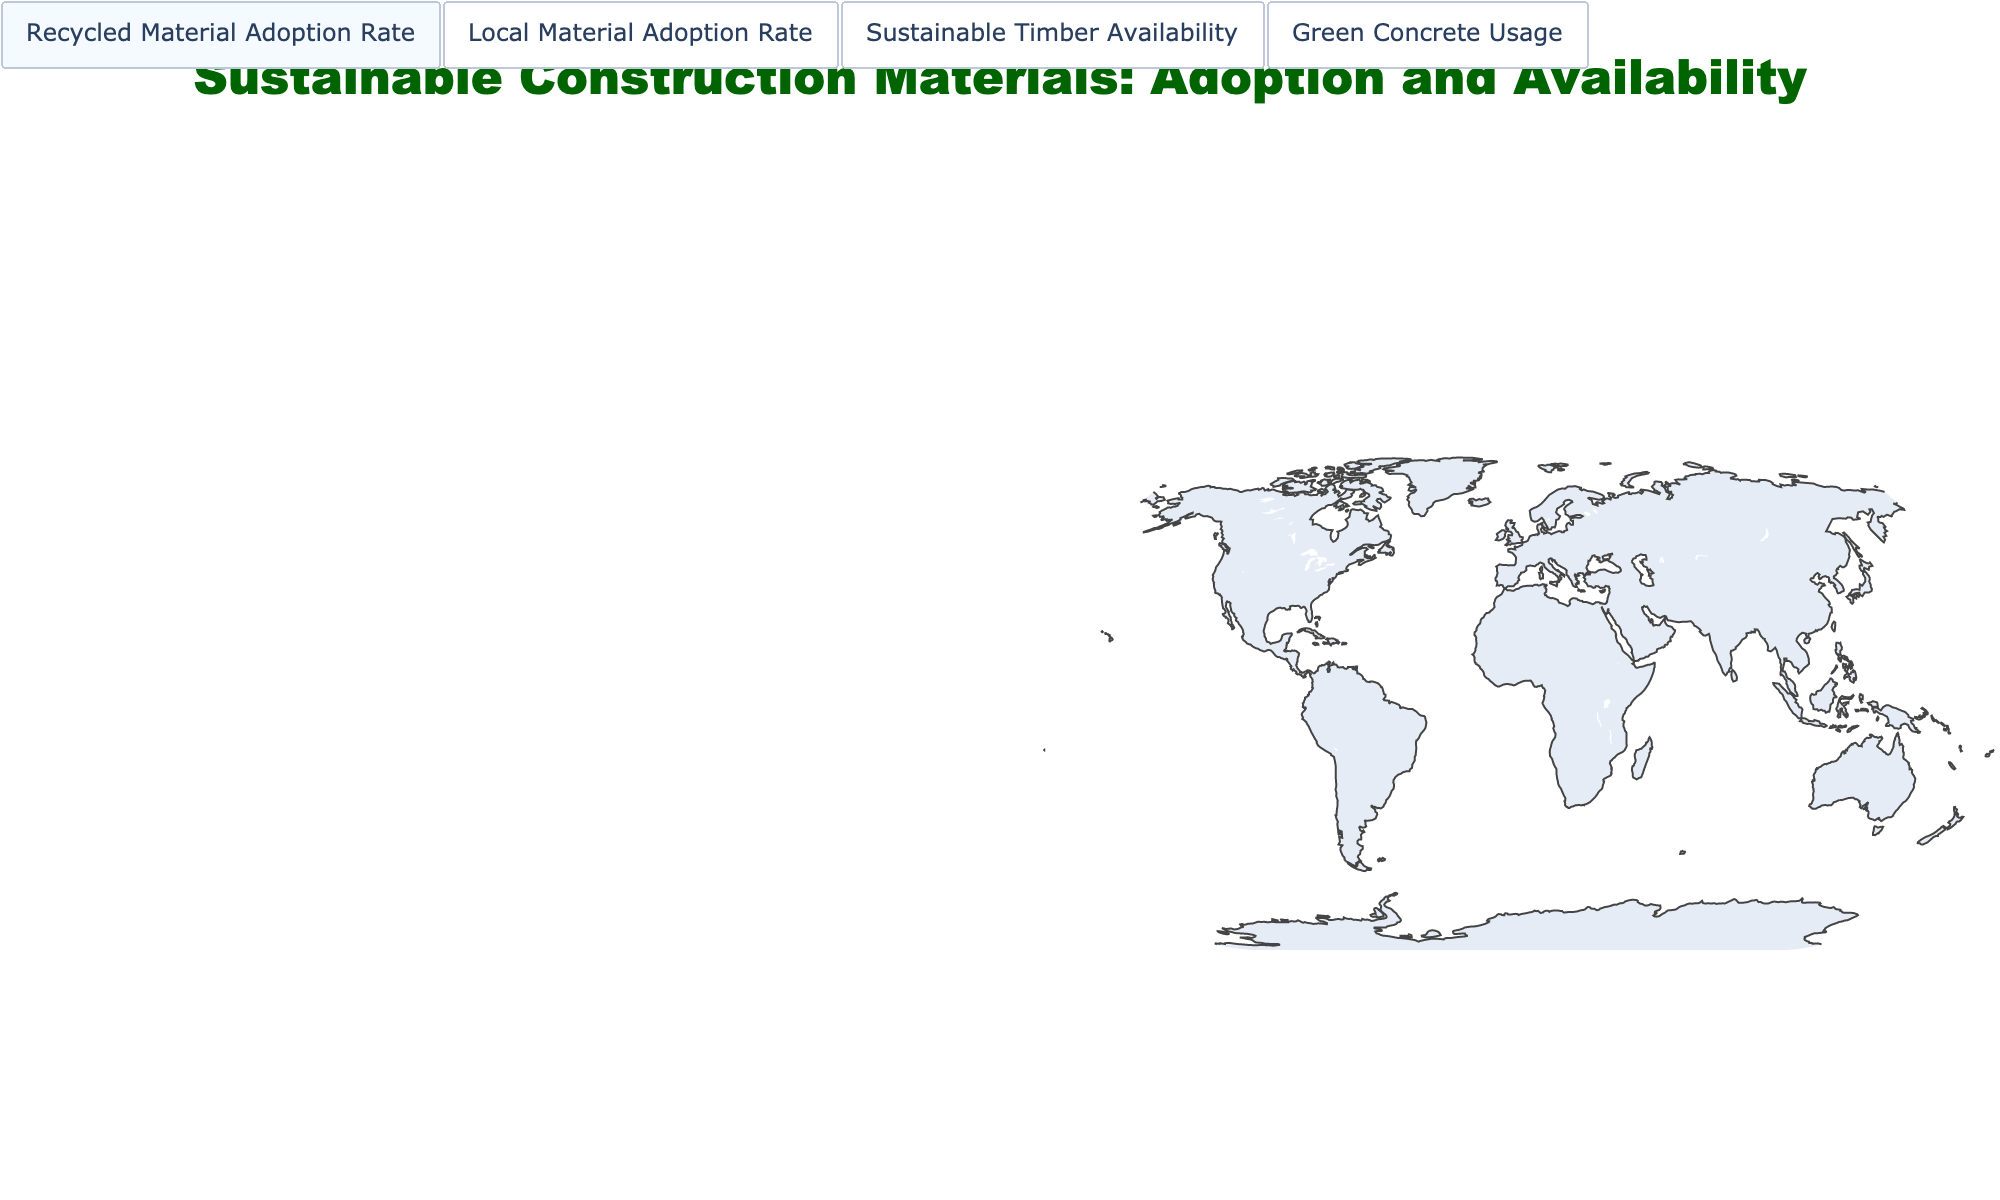What is the title of the figure? The title of the figure is typically found at the top center of the image, usually presented in a larger and bold font. In this figure, it is stated as "Sustainable Construction Materials: Adoption and Availability".
Answer: Sustainable Construction Materials: Adoption and Availability Which country has the highest adoption rate for recycled materials? Look at the Choropleth legend for "Recycled Material Adoption Rate" and locate the country with the darkest color, which indicates the highest value. According to the data, Sweden has the highest adoption rate at 85%.
Answer: Sweden How does Green Concrete Usage in the United Kingdom compare to that in Germany? Locate both the United Kingdom and Germany in the Green Concrete Usage plot. The shaded regions will differ in color intensity based on the usage rates. The United Kingdom has a usage rate of 76%, while Germany has a higher rate at 83%.
Answer: Germany has a higher usage rate What is the average availability of Sustainable Timber across all listed countries? Sum the Sustainable Timber Availability values for all countries then divide by the number of countries. (72 + 68 + 45 + 58 + 90 + 95 + 52 + 88 + 40 + 35 + 62 + 30)/12 = 53.5.
Answer: 53.5 Which countries have an Adoption Rate of Local Materials above 75%? Review the plot corresponding to Local Material Adoption Rate and identify the countries with values greater than 75%. These countries are Australia, Brazil, India, and South Africa.
Answer: Australia, Brazil, India, South Africa Can you compare the Sustainable Timber Availability between Canada and Japan? Observe the Choropleth plot for Sustainable Timber Availability. Canada has a value of 95, while Japan has 45. Canada’s availability is significantly higher.
Answer: Canada has significantly higher availability Which countries have the lowest and highest Green Concrete Usage, and what are their respective rates? Identify the countries with the lightest and darkest colors in the "Green Concrete Usage" plot. United Arab Emirates has the highest at 71% while South Africa has the lowest at 45%.
Answer: United Arab Emirates (71%), South Africa (45%) What is the overall trend seen in the adoption of Local Materials among the listed countries? Look at the color intensity across all countries for Local Material Adoption Rate. Many countries fall within a high range (e.g., Brazil at 85% and India at 88%), indicating a strong adoption trend globally.
Answer: High adoption rate trend globally What relationship can you infer between the availability of Sustainable Timber and Recycled Material Adoption Rate? Compare the two plots for any significant patterns. For example, Sweden has high values in both metrics (88% and 85%). Generally, countries with higher timber availability also tend to adopt recycled materials extensively.
Answer: Higher timber availability tends to coincide with higher adoption of recycled materials How does South Africa’s Local Material Adoption Rate compare to its Recycled Material Adoption Rate? Locate South Africa on the plots for both metrics. It has a Local Material Adoption Rate of 82% and a Recycled Material Adoption Rate of 50%. The Local Material Adoption Rate is notably higher.
Answer: Local Material Adoption Rate is higher 